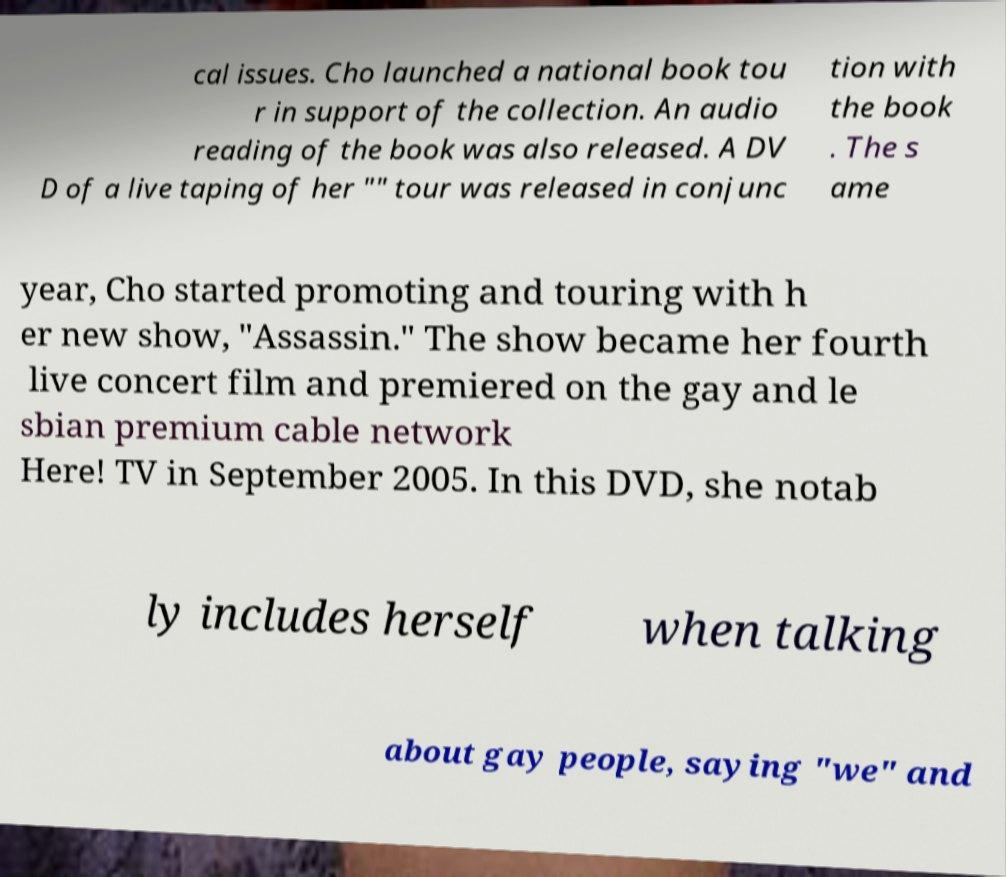Could you assist in decoding the text presented in this image and type it out clearly? cal issues. Cho launched a national book tou r in support of the collection. An audio reading of the book was also released. A DV D of a live taping of her "" tour was released in conjunc tion with the book . The s ame year, Cho started promoting and touring with h er new show, "Assassin." The show became her fourth live concert film and premiered on the gay and le sbian premium cable network Here! TV in September 2005. In this DVD, she notab ly includes herself when talking about gay people, saying "we" and 